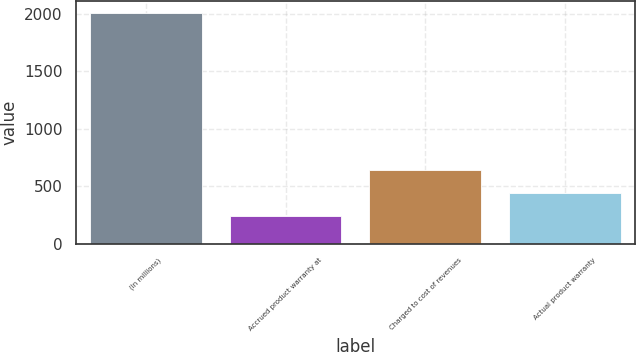Convert chart to OTSL. <chart><loc_0><loc_0><loc_500><loc_500><bar_chart><fcel>(In millions)<fcel>Accrued product warranty at<fcel>Charged to cost of revenues<fcel>Actual product warranty<nl><fcel>2012<fcel>246.29<fcel>638.67<fcel>442.48<nl></chart> 